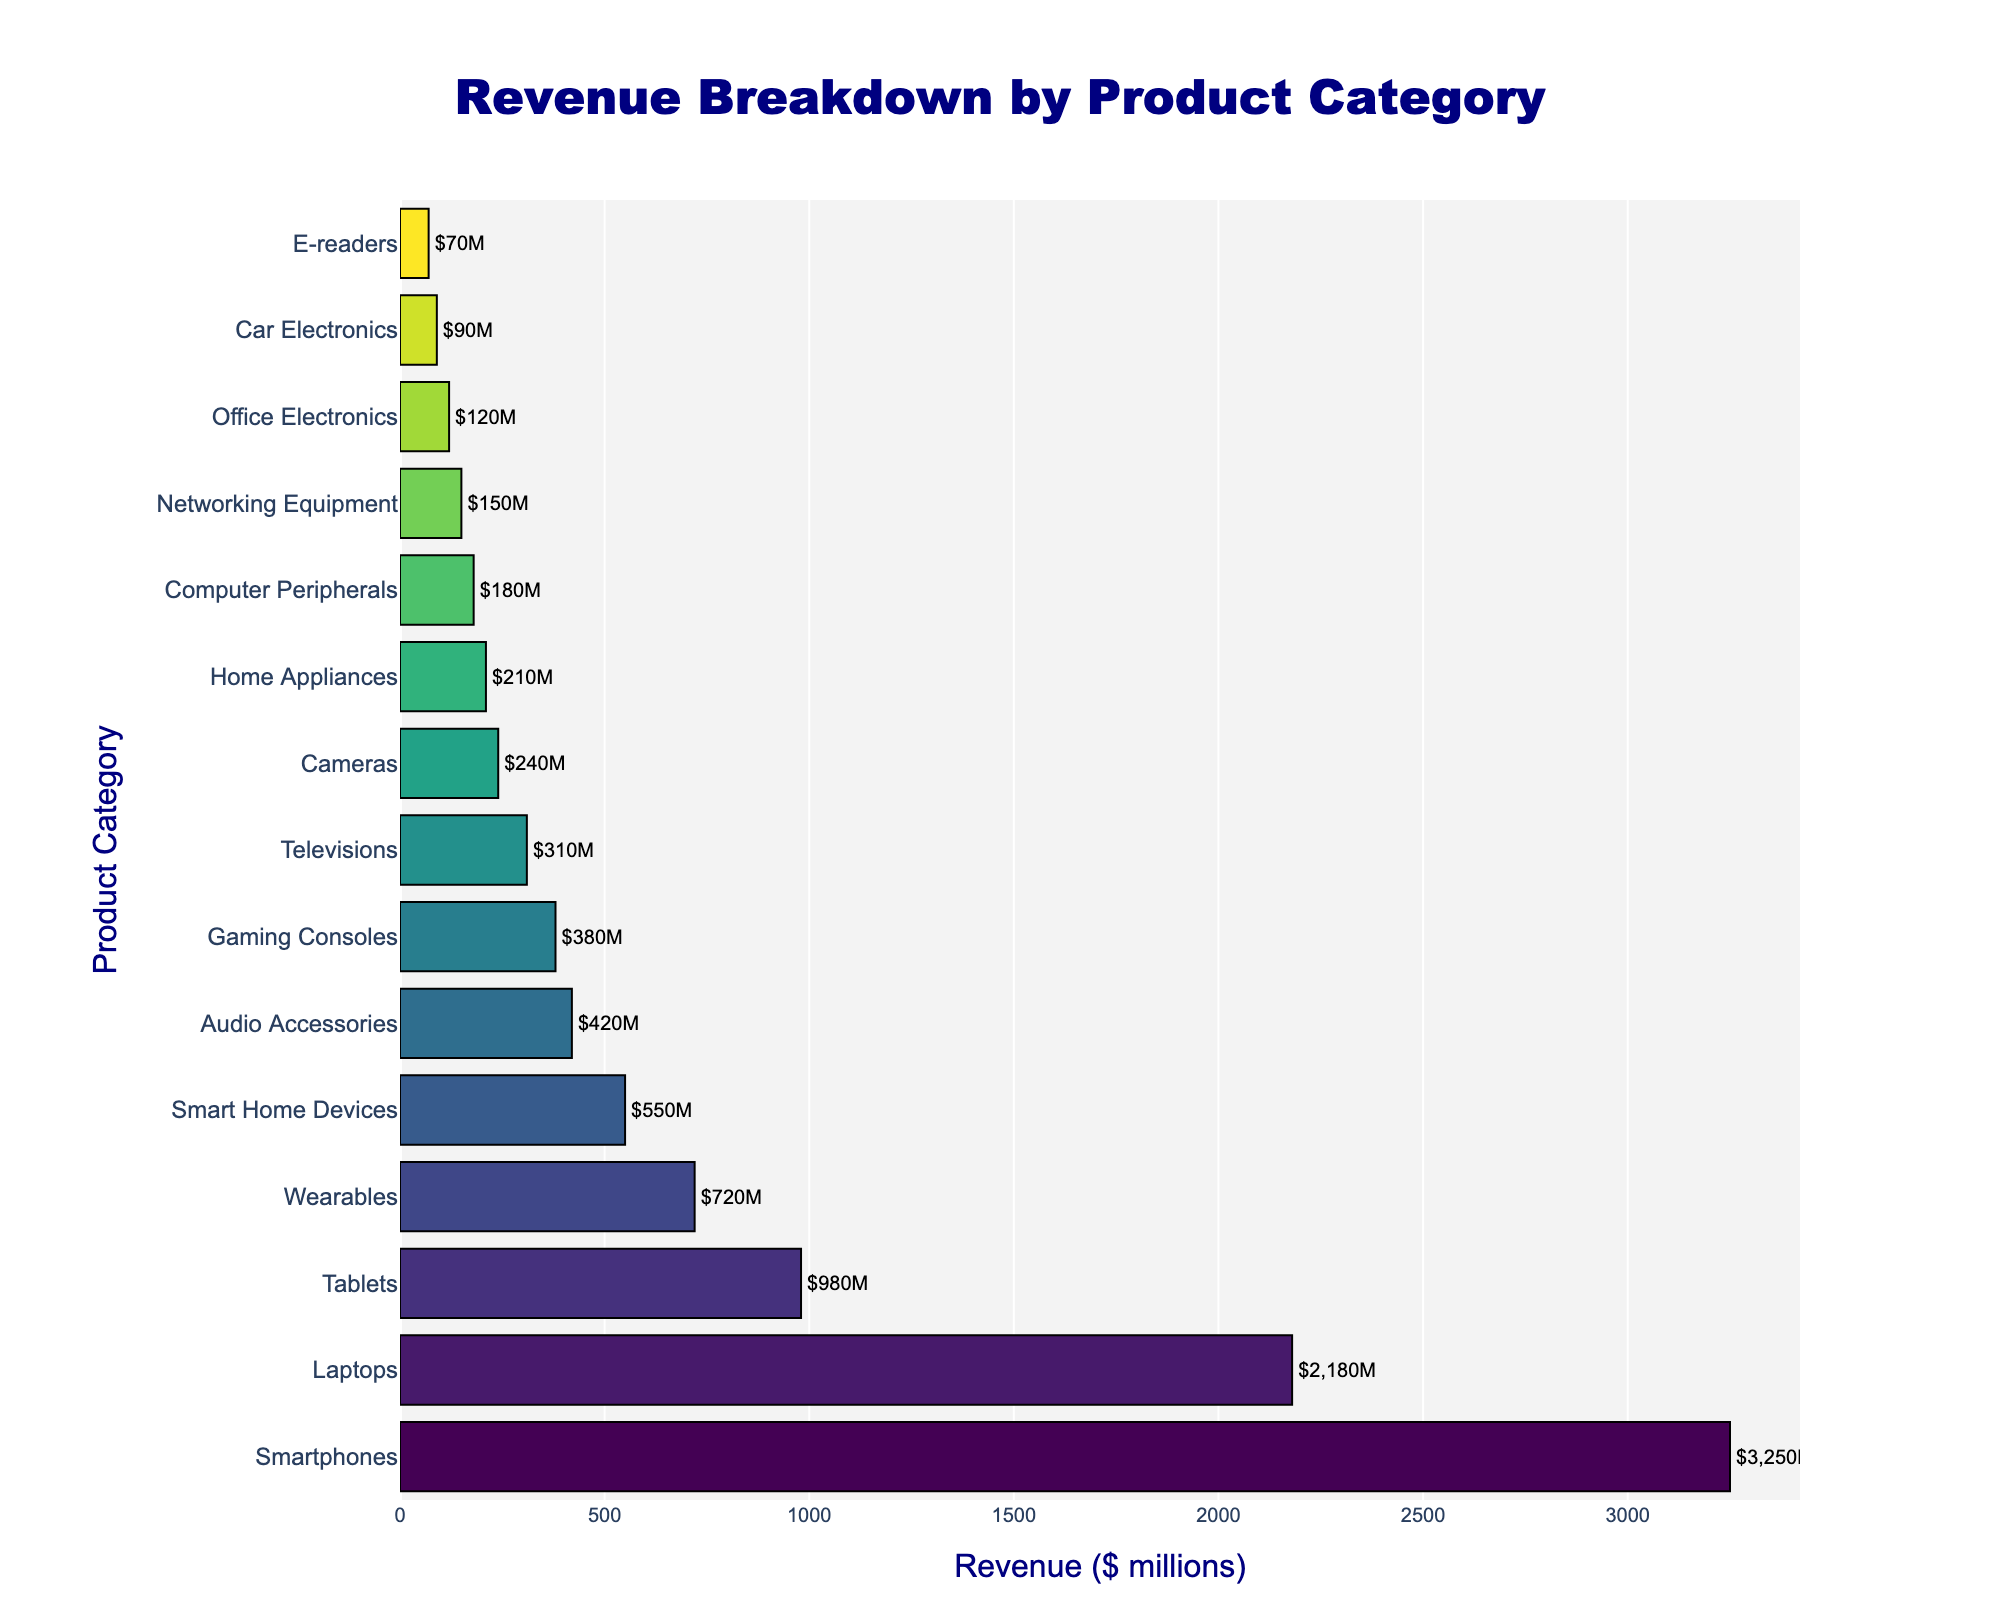Which product category generated the highest revenue? The figure shows a horizontal bar chart with the revenue amounts for each product category. The longest bar corresponds to "Smartphones" with $3,250 million.
Answer: Smartphones What is the combined revenue of the top three product categories? To find the combined revenue, sum the revenues of the top three categories: Smartphones ($3,250 million), Laptops ($2,180 million), and Tablets ($980 million). The combined revenue is $3,250 + $2,180 + $980 = $6,410 million.
Answer: $6,410 million Which product category has the lowest revenue and how much is it? The shortest bar in the chart corresponds to "E-readers," with a revenue of $70 million.
Answer: E-readers, $70 million How much more revenue did Laptops generate compared to Wearables? The revenue for Laptops is $2,180 million, and for Wearables, it is $720 million. The difference in revenue is $2,180 - $720 = $1,460 million.
Answer: $1,460 million How many product categories generated more than $1 billion in revenue? By looking at the bars and their labels, we can see that Smartphones, Laptops, and Tablets generated more than $1 billion. So, there are 3 categories.
Answer: 3 What is the total revenue generated by the categories with revenues less than $500 million? Identify the categories under $500 million: Smart Home Devices, Audio Accessories, Gaming Consoles, Televisions, Cameras, Home Appliances, Computer Peripherals, Networking Equipment, Office Electronics, Car Electronics, and E-readers. Sum their revenues: $550 + $420 + $380 + $310 + $240 + $210 + $180 + $150 + $120 + $90 + $70 = $2,720 million.
Answer: $2,720 million Which two product categories have revenues closest to each other, and what are their revenues? By observing the lengths of the bars, Cameras and Home Appliances appear to have close revenues. Cameras have $240 million, and Home Appliances have $210 million. The difference is $30 million.
Answer: Cameras ($240 million) and Home Appliances ($210 million) Does the revenue of Tablets exceed the combined revenue of all categories with less than $300 million in revenue? Calculate the combined revenue for categories with less than $300 million: Televisions ($310 million) are just above, so consider Cameras ($240 million), Home Appliances ($210 million), Computer Peripherals ($180 million), Networking Equipment ($150 million), Office Electronics ($120 million), Car Electronics ($90 million), E-readers ($70 million). Their combined revenue is $240 + $210 + $180 + $150 + $120 + $90 + $70 = $1,060 million. Since Tablets generated $980 million, it does not exceed $1,060 million.
Answer: No What is the percentage of total revenue contributed by Audio Accessories? Calculate the total revenue for all categories combined. Sum all values: $3,250 (Smartphones) + $2,180 (Laptops) + $980 (Tablets) + $720 (Wearables) + $550 (Smart Home Devices) + $420 (Audio Accessories) + $380 (Gaming Consoles) + $310 (Televisions) + $240 (Cameras) + $210 (Home Appliances) + $180 (Computer Peripherals) + $150 (Networking Equipment) + $120 (Office Electronics) + $90 (Car Electronics) + $70 (E-readers) = $9,850 million. The percentage for Audio Accessories = ($420 / $9,850) * 100 ≈ 4.3%.
Answer: 4.3% 